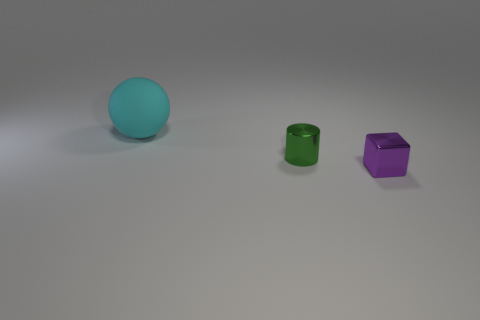Add 2 big green matte blocks. How many objects exist? 5 Subtract all cylinders. How many objects are left? 2 Add 3 tiny cyan matte blocks. How many tiny cyan matte blocks exist? 3 Subtract 1 purple blocks. How many objects are left? 2 Subtract all red metallic things. Subtract all purple cubes. How many objects are left? 2 Add 1 tiny things. How many tiny things are left? 3 